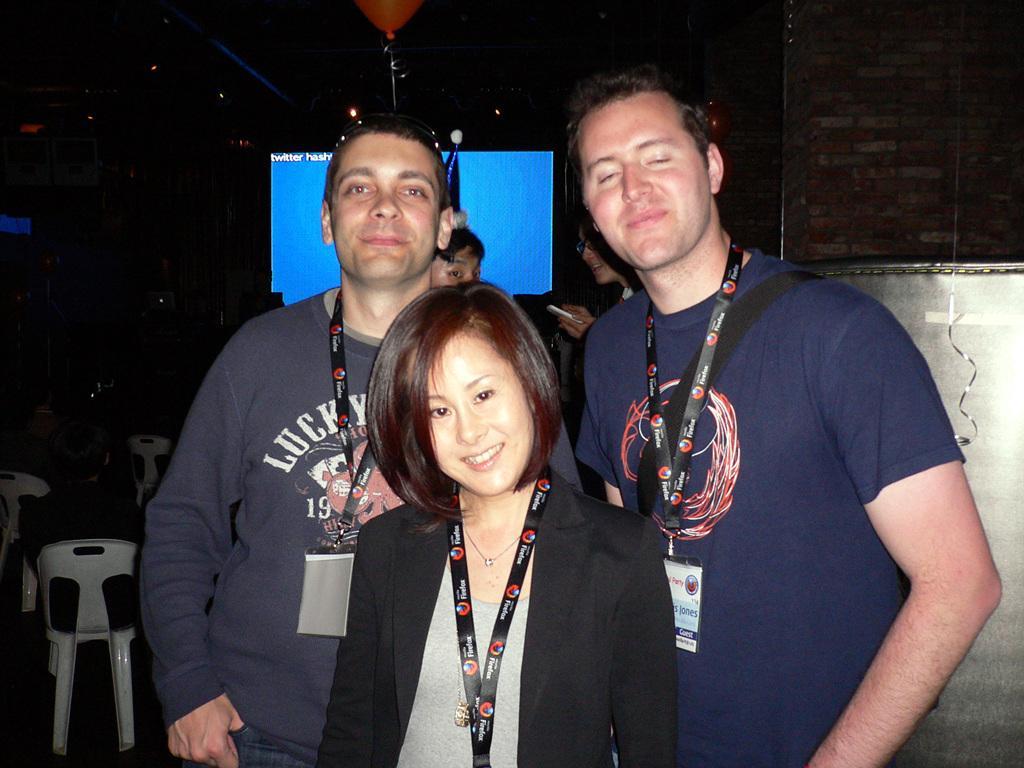Could you give a brief overview of what you see in this image? This is an image clicked in the dark. Here I can see two men and a woman standing, smiling and giving pose for the picture. At the back of these people I can see two more persons. On the left side, I can see few people are sitting on the chairs. In the background, I can see a screen in the dark. On the right side, I can see a wall. 